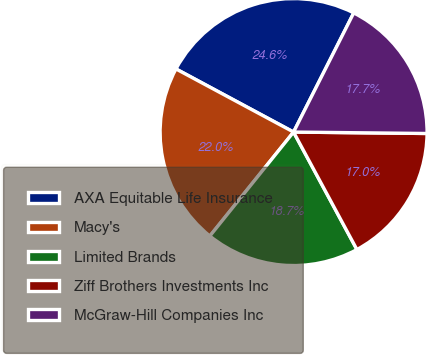Convert chart to OTSL. <chart><loc_0><loc_0><loc_500><loc_500><pie_chart><fcel>AXA Equitable Life Insurance<fcel>Macy's<fcel>Limited Brands<fcel>Ziff Brothers Investments Inc<fcel>McGraw-Hill Companies Inc<nl><fcel>24.6%<fcel>22.05%<fcel>18.66%<fcel>16.96%<fcel>17.73%<nl></chart> 